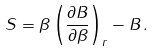Convert formula to latex. <formula><loc_0><loc_0><loc_500><loc_500>S = \beta \left ( \frac { \partial B } { \partial \beta } \right ) _ { r } - B \, .</formula> 